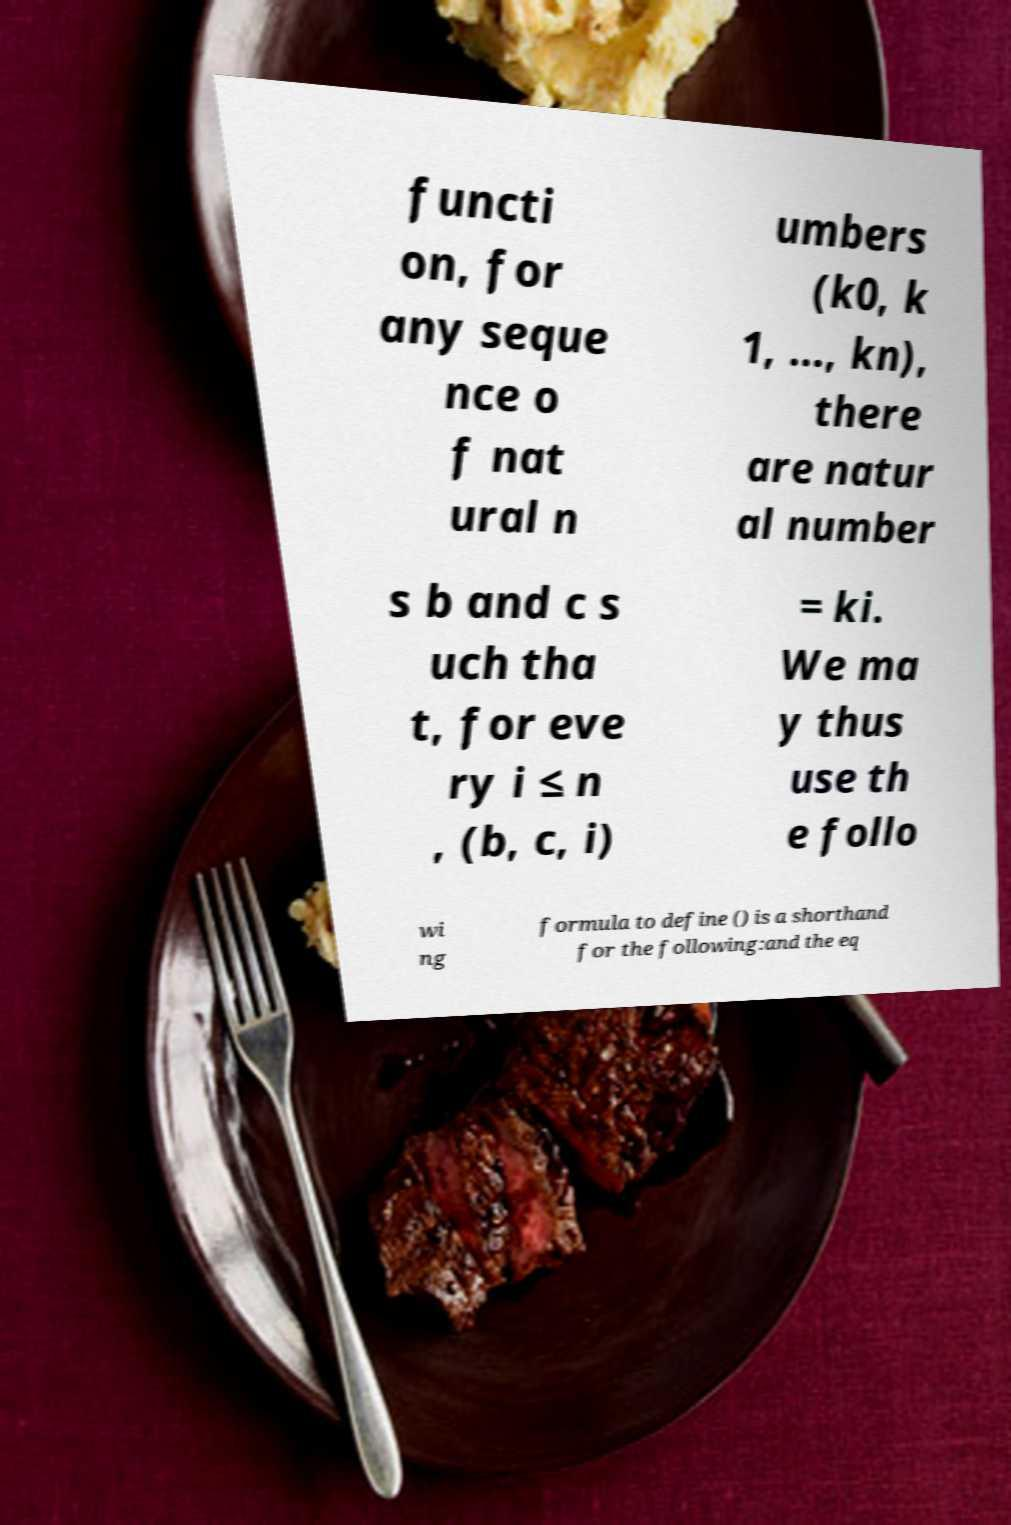Could you extract and type out the text from this image? functi on, for any seque nce o f nat ural n umbers (k0, k 1, ..., kn), there are natur al number s b and c s uch tha t, for eve ry i ≤ n , (b, c, i) = ki. We ma y thus use th e follo wi ng formula to define () is a shorthand for the following:and the eq 